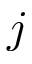<formula> <loc_0><loc_0><loc_500><loc_500>j</formula> 